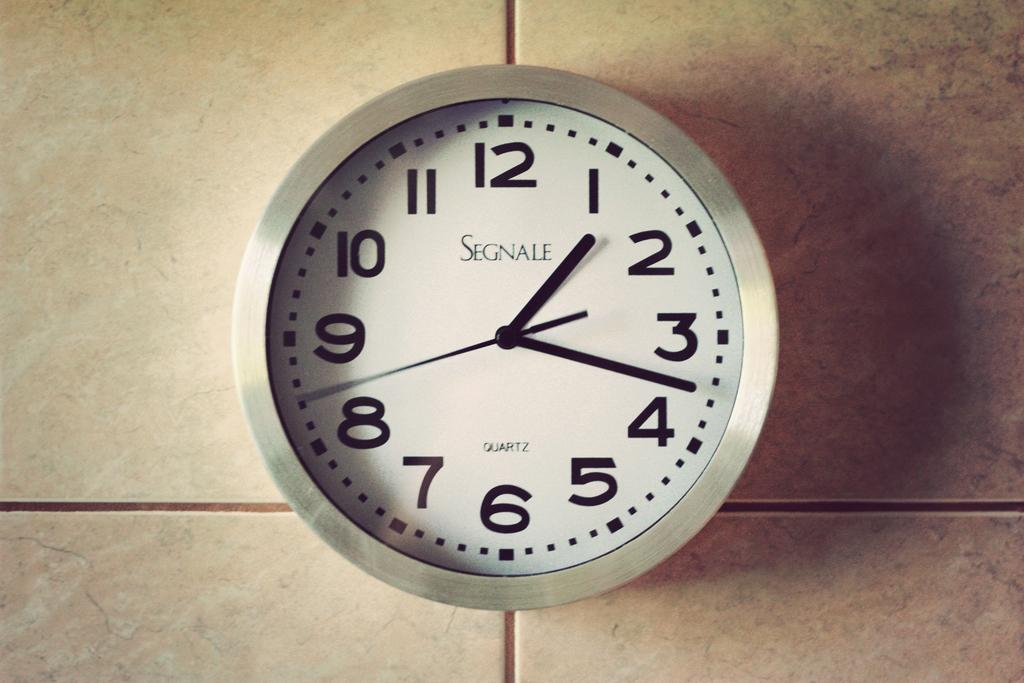Provide a one-sentence caption for the provided image. An analog wall clock with the word SEGNALE in the center. 